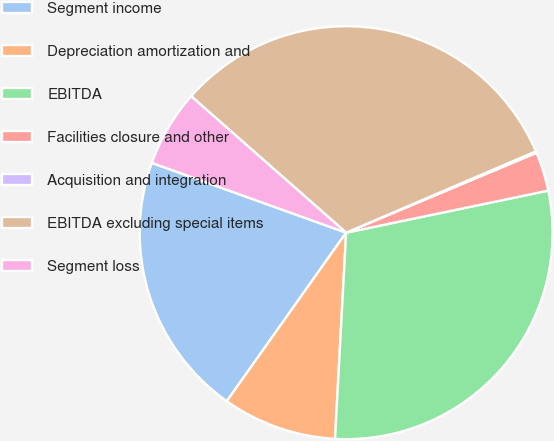Convert chart. <chart><loc_0><loc_0><loc_500><loc_500><pie_chart><fcel>Segment income<fcel>Depreciation amortization and<fcel>EBITDA<fcel>Facilities closure and other<fcel>Acquisition and integration<fcel>EBITDA excluding special items<fcel>Segment loss<nl><fcel>20.68%<fcel>8.95%<fcel>29.12%<fcel>3.06%<fcel>0.12%<fcel>32.06%<fcel>6.0%<nl></chart> 